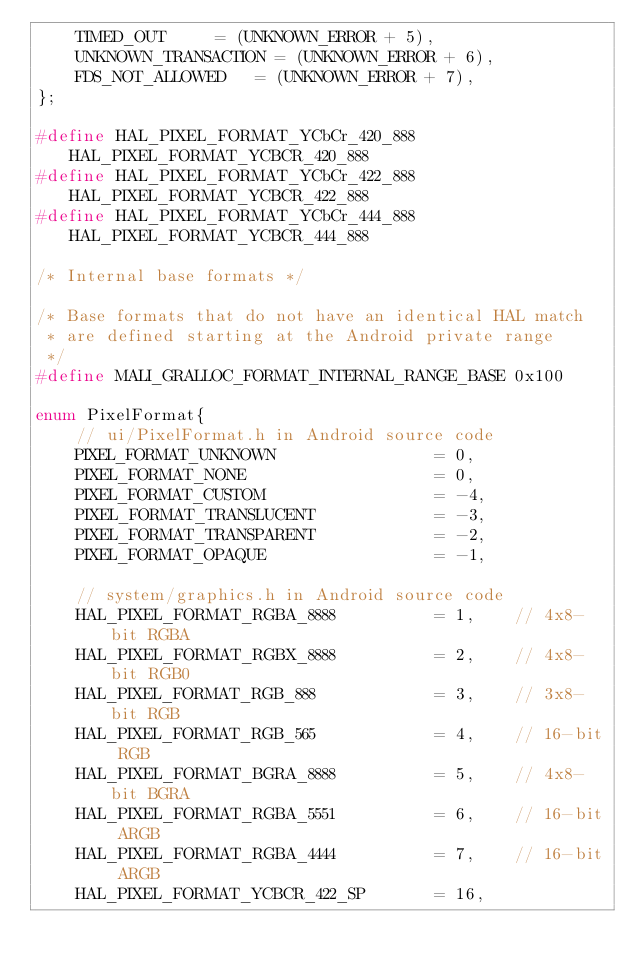Convert code to text. <code><loc_0><loc_0><loc_500><loc_500><_C++_>    TIMED_OUT			= (UNKNOWN_ERROR + 5),
    UNKNOWN_TRANSACTION = (UNKNOWN_ERROR + 6),
    FDS_NOT_ALLOWED		= (UNKNOWN_ERROR + 7),
};

#define HAL_PIXEL_FORMAT_YCbCr_420_888 HAL_PIXEL_FORMAT_YCBCR_420_888
#define HAL_PIXEL_FORMAT_YCbCr_422_888 HAL_PIXEL_FORMAT_YCBCR_422_888
#define HAL_PIXEL_FORMAT_YCbCr_444_888 HAL_PIXEL_FORMAT_YCBCR_444_888

/* Internal base formats */

/* Base formats that do not have an identical HAL match
 * are defined starting at the Android private range
 */
#define MALI_GRALLOC_FORMAT_INTERNAL_RANGE_BASE 0x100

enum PixelFormat{
    // ui/PixelFormat.h in Android source code
    PIXEL_FORMAT_UNKNOWN                = 0,
    PIXEL_FORMAT_NONE                   = 0,
    PIXEL_FORMAT_CUSTOM                 = -4,
    PIXEL_FORMAT_TRANSLUCENT            = -3,
    PIXEL_FORMAT_TRANSPARENT            = -2,
    PIXEL_FORMAT_OPAQUE                 = -1,

    // system/graphics.h in Android source code
    HAL_PIXEL_FORMAT_RGBA_8888          = 1,    // 4x8-bit RGBA
    HAL_PIXEL_FORMAT_RGBX_8888          = 2,    // 4x8-bit RGB0
    HAL_PIXEL_FORMAT_RGB_888            = 3,    // 3x8-bit RGB
    HAL_PIXEL_FORMAT_RGB_565            = 4,    // 16-bit RGB
    HAL_PIXEL_FORMAT_BGRA_8888          = 5,    // 4x8-bit BGRA
    HAL_PIXEL_FORMAT_RGBA_5551          = 6,    // 16-bit ARGB
    HAL_PIXEL_FORMAT_RGBA_4444          = 7,    // 16-bit ARGB
    HAL_PIXEL_FORMAT_YCBCR_422_SP       = 16,</code> 